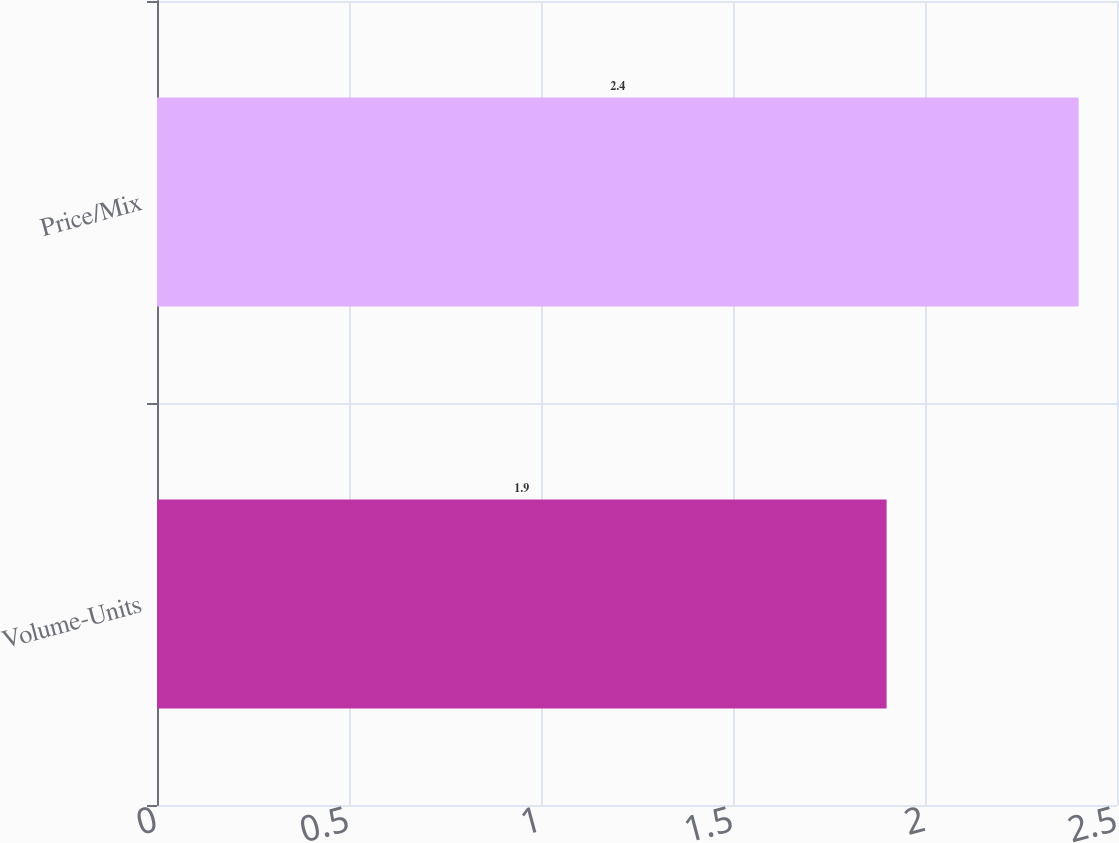<chart> <loc_0><loc_0><loc_500><loc_500><bar_chart><fcel>Volume-Units<fcel>Price/Mix<nl><fcel>1.9<fcel>2.4<nl></chart> 